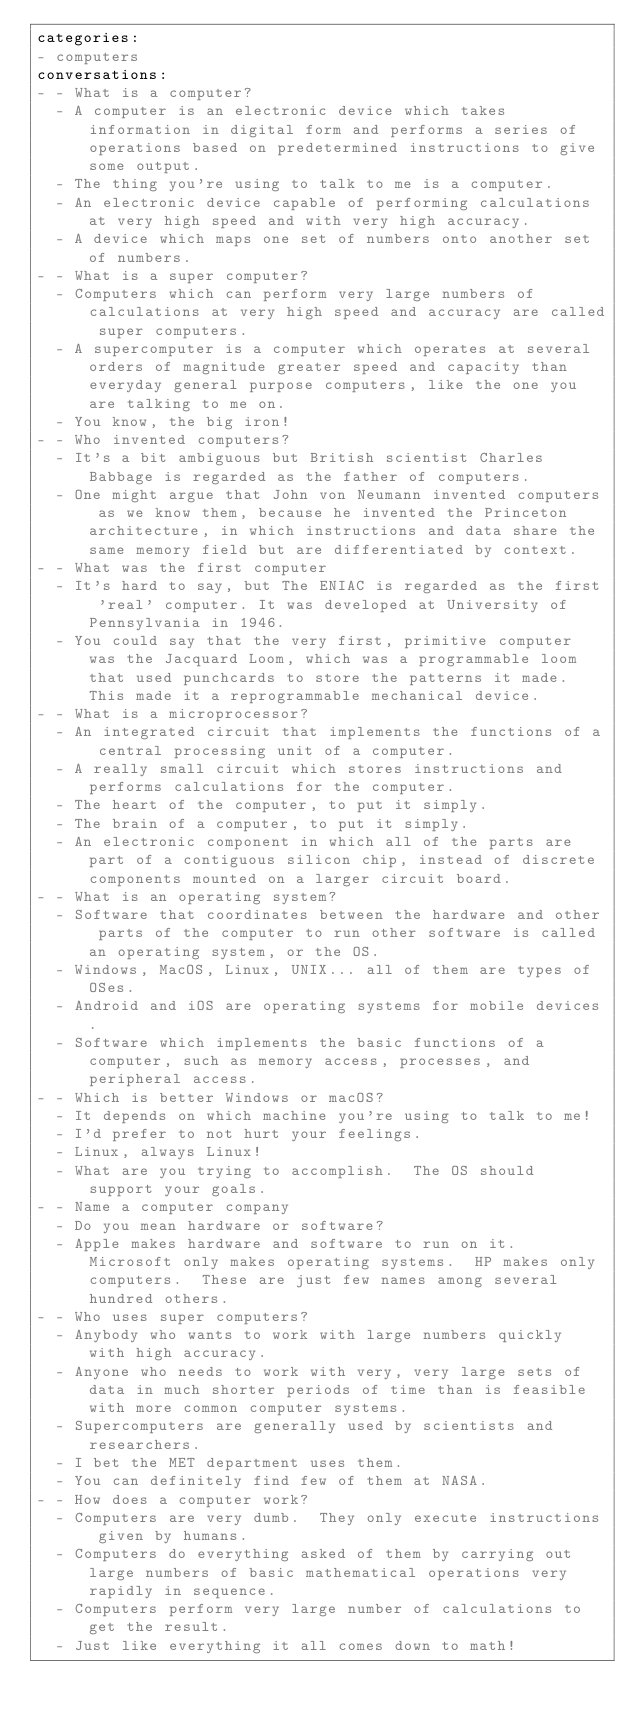Convert code to text. <code><loc_0><loc_0><loc_500><loc_500><_YAML_>categories:
- computers
conversations:
- - What is a computer?
  - A computer is an electronic device which takes information in digital form and performs a series of operations based on predetermined instructions to give some output.
  - The thing you're using to talk to me is a computer.
  - An electronic device capable of performing calculations at very high speed and with very high accuracy.
  - A device which maps one set of numbers onto another set of numbers.
- - What is a super computer?
  - Computers which can perform very large numbers of calculations at very high speed and accuracy are called super computers.
  - A supercomputer is a computer which operates at several orders of magnitude greater speed and capacity than everyday general purpose computers, like the one you are talking to me on.
  - You know, the big iron!
- - Who invented computers?
  - It's a bit ambiguous but British scientist Charles Babbage is regarded as the father of computers.
  - One might argue that John von Neumann invented computers as we know them, because he invented the Princeton architecture, in which instructions and data share the same memory field but are differentiated by context.
- - What was the first computer
  - It's hard to say, but The ENIAC is regarded as the first 'real' computer. It was developed at University of Pennsylvania in 1946.
  - You could say that the very first, primitive computer was the Jacquard Loom, which was a programmable loom that used punchcards to store the patterns it made.  This made it a reprogrammable mechanical device.
- - What is a microprocessor?
  - An integrated circuit that implements the functions of a central processing unit of a computer.
  - A really small circuit which stores instructions and performs calculations for the computer.
  - The heart of the computer, to put it simply.
  - The brain of a computer, to put it simply.
  - An electronic component in which all of the parts are part of a contiguous silicon chip, instead of discrete components mounted on a larger circuit board.
- - What is an operating system?
  - Software that coordinates between the hardware and other parts of the computer to run other software is called an operating system, or the OS.
  - Windows, MacOS, Linux, UNIX... all of them are types of OSes.
  - Android and iOS are operating systems for mobile devices.
  - Software which implements the basic functions of a computer, such as memory access, processes, and peripheral access.
- - Which is better Windows or macOS?
  - It depends on which machine you're using to talk to me!
  - I'd prefer to not hurt your feelings.
  - Linux, always Linux!
  - What are you trying to accomplish.  The OS should support your goals.
- - Name a computer company
  - Do you mean hardware or software?
  - Apple makes hardware and software to run on it.  Microsoft only makes operating systems.  HP makes only computers.  These are just few names among several hundred others.
- - Who uses super computers?
  - Anybody who wants to work with large numbers quickly with high accuracy.
  - Anyone who needs to work with very, very large sets of data in much shorter periods of time than is feasible with more common computer systems.
  - Supercomputers are generally used by scientists and researchers.
  - I bet the MET department uses them.
  - You can definitely find few of them at NASA.
- - How does a computer work?
  - Computers are very dumb.  They only execute instructions given by humans.
  - Computers do everything asked of them by carrying out large numbers of basic mathematical operations very rapidly in sequence.
  - Computers perform very large number of calculations to get the result.
  - Just like everything it all comes down to math!
</code> 